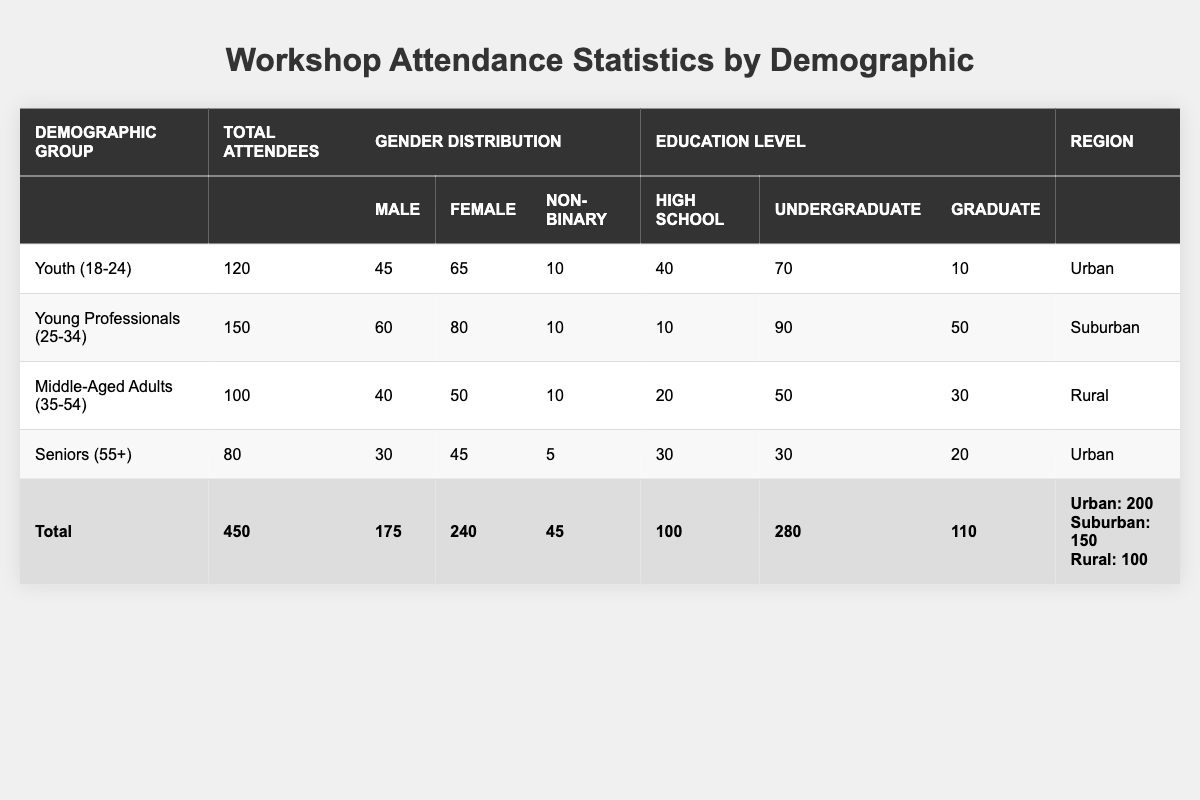What is the total number of attendees across all demographic groups? The total number of attendees is provided in the last row of the table as "Total," which shows 450 attendees across all groups.
Answer: 450 How many male attendees were there in the Young Professionals (25-34) group? In the row for Young Professionals (25-34), the gender distribution shows that there were 60 male attendees.
Answer: 60 What is the total number of female attendees across all groups? To find the total number of female attendees, look at the gender distribution for each group: 65 (Youth) + 80 (Young Professionals) + 50 (Middle-Aged) + 45 (Seniors) = 240. The total is 240 female attendees.
Answer: 240 Which demographic group had the highest number of attendees? By examining the "Total Attendees" column, the group with the highest number is "Young Professionals (25-34)" with 150 attendees.
Answer: Young Professionals (25-34) How many total attendees were from the Rural region? The total number of attendees from the Rural region is mentioned in the last row under the "Region" column, which states there were 100 attendees.
Answer: 100 What percentage of attendees were non-binary in the Youth (18-24) group? To calculate the percentage of non-binary attendees in the Youth (18-24) group, take the number of non-binary (10) and divide by the total attendees (120), then multiply by 100: (10 / 120) * 100 = 8.33%.
Answer: 8.33% What is the average number of attendees per education level category (High School, Undergraduate, Graduate) in the Total row? The total attendees for education levels sum up to 100 (High School) + 280 (Undergraduate) + 110 (Graduate) = 490. There are three categories, so to find the average, divide 490 by 3: 490 / 3 = approximately 163.33.
Answer: 163.33 True or False: The total number of male attendees is greater than the total number of graduate-level attendees. The total number of male attendees is 175 (from the Total row), while graduate-level attendees total 110. Since 175 is greater than 110, the statement is true.
Answer: True How does the gender distribution compare for the Seniors (55+) and Middle-Aged Adults (35-54) groups? For Seniors (55+), there were 30 male, 45 female, and 5 non-binary attendees. For Middle-Aged Adults (35-54), there were 40 male, 50 female, and 10 non-binary attendees. Comparing the two, the Middle-Aged group had more male attendees and slightly more female attendees.
Answer: Middle-Aged had more males and slightly more females What is the difference in attendance between the Urban and Suburban regions? From the Total row, Urban has 200 attendees, and Suburban has 150. The difference is 200 - 150 = 50 attendees.
Answer: 50 